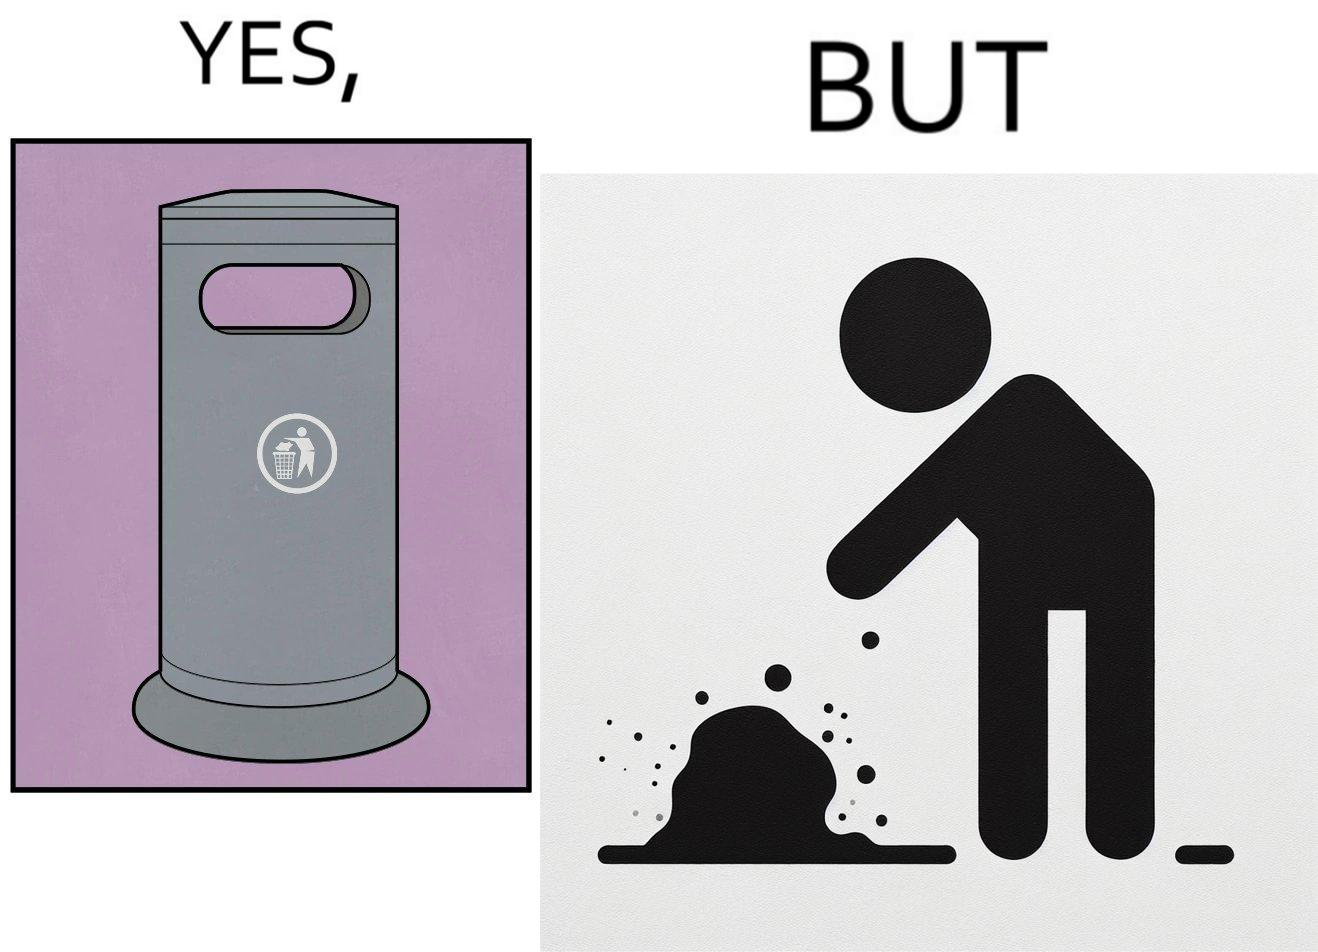Describe what you see in the left and right parts of this image. In the left part of the image: It is a garbage bin In the right part of the image: It is a human hand sticking chewing gum on public property 